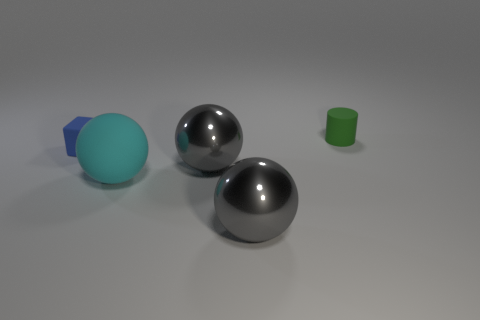There is a rubber object that is behind the blue matte object; are there any rubber balls that are on the right side of it?
Your response must be concise. No. There is a tiny matte thing in front of the small green object; how many gray shiny things are on the right side of it?
Offer a very short reply. 2. There is a thing that is the same size as the rubber cylinder; what material is it?
Provide a succinct answer. Rubber. There is a tiny green thing that is right of the big cyan rubber object; is it the same shape as the tiny blue thing?
Ensure brevity in your answer.  No. Are there more cyan rubber spheres that are to the left of the green thing than blue objects that are to the left of the tiny block?
Provide a succinct answer. Yes. How many green objects are the same material as the blue object?
Provide a succinct answer. 1. Is the green thing the same size as the rubber cube?
Offer a terse response. Yes. The large rubber thing has what color?
Keep it short and to the point. Cyan. How many objects are big red metallic balls or small blue blocks?
Your response must be concise. 1. Is there another large matte thing of the same shape as the blue rubber thing?
Ensure brevity in your answer.  No. 